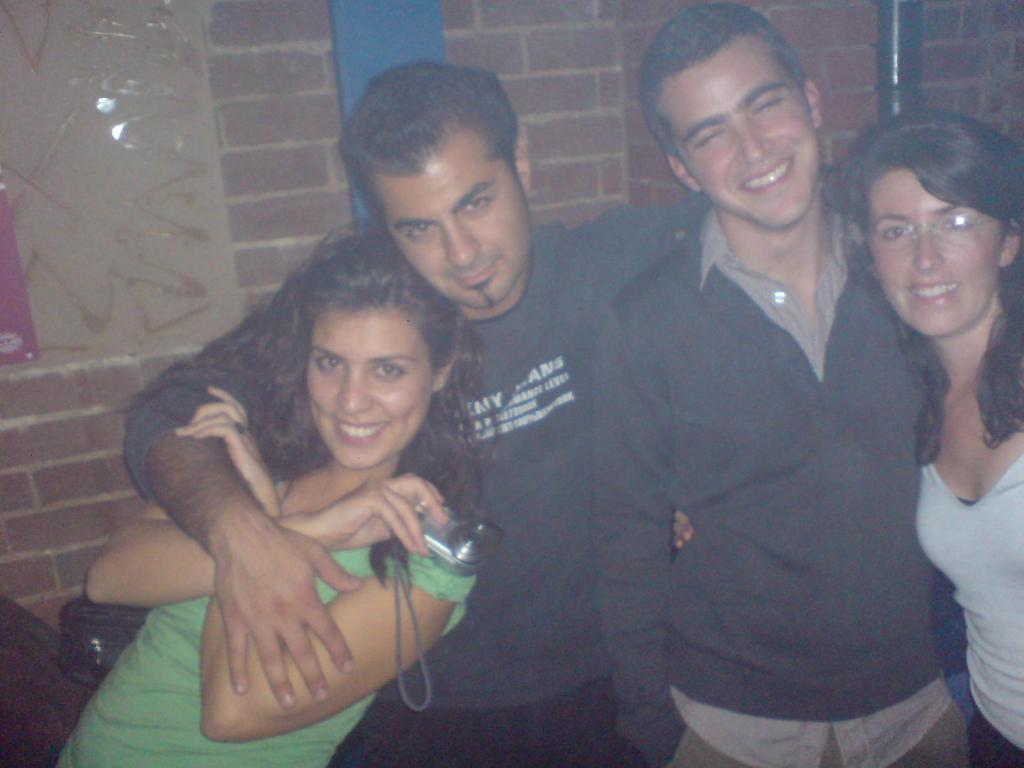How many people are present in the image? There are four people standing in the image. What can be seen in the background of the image? There is a wall in the background of the image. Are there any objects or structures visible in the image? Yes, there is a pole in the image. What type of flowers can be seen growing near the pole in the image? There are no flowers visible in the image; only the four people, the wall, and the pole are present. 